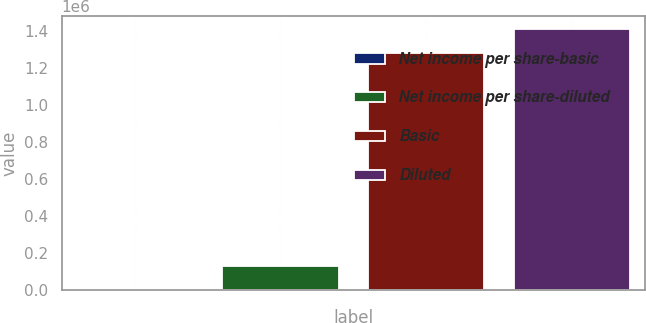Convert chart to OTSL. <chart><loc_0><loc_0><loc_500><loc_500><bar_chart><fcel>Net income per share-basic<fcel>Net income per share-diluted<fcel>Basic<fcel>Diluted<nl><fcel>0.29<fcel>128428<fcel>1.27954e+06<fcel>1.40796e+06<nl></chart> 